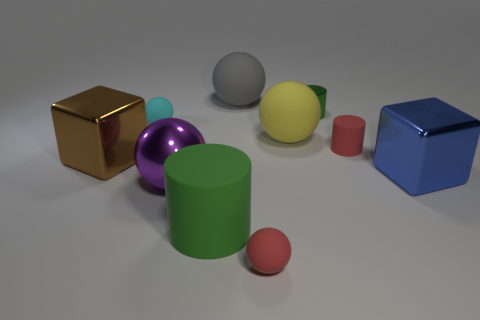Are there any small matte spheres that have the same color as the metal sphere?
Offer a terse response. No. Are any tiny cyan metallic things visible?
Offer a terse response. No. Does the blue metal block in front of the green metallic cylinder have the same size as the big shiny ball?
Make the answer very short. Yes. Are there fewer big purple shiny things than cylinders?
Make the answer very short. Yes. What shape is the green object in front of the block that is right of the tiny cylinder in front of the tiny cyan thing?
Provide a short and direct response. Cylinder. Are there any tiny green cylinders made of the same material as the yellow ball?
Keep it short and to the point. No. There is a large rubber thing in front of the large blue thing; is its color the same as the big object that is right of the green metallic thing?
Give a very brief answer. No. Are there fewer large balls that are in front of the big green rubber cylinder than purple rubber things?
Offer a very short reply. No. How many objects are small red matte balls or large blocks that are right of the big brown cube?
Your answer should be compact. 2. What is the color of the tiny cylinder that is the same material as the large brown thing?
Make the answer very short. Green. 